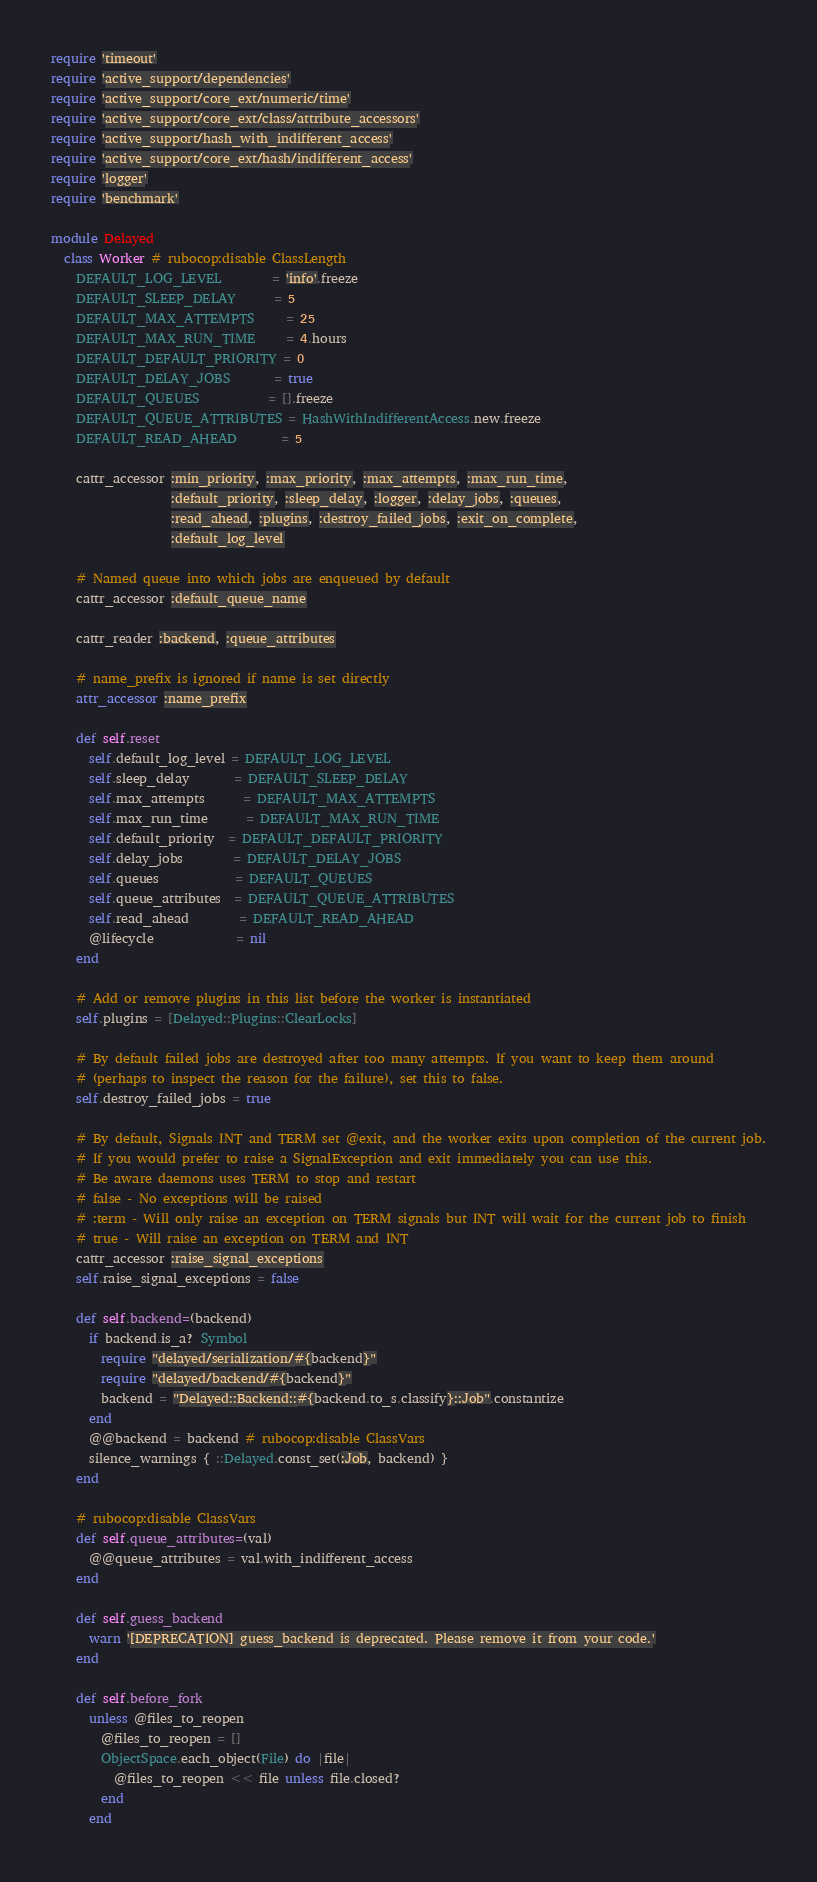<code> <loc_0><loc_0><loc_500><loc_500><_Ruby_>require 'timeout'
require 'active_support/dependencies'
require 'active_support/core_ext/numeric/time'
require 'active_support/core_ext/class/attribute_accessors'
require 'active_support/hash_with_indifferent_access'
require 'active_support/core_ext/hash/indifferent_access'
require 'logger'
require 'benchmark'

module Delayed
  class Worker # rubocop:disable ClassLength
    DEFAULT_LOG_LEVEL        = 'info'.freeze
    DEFAULT_SLEEP_DELAY      = 5
    DEFAULT_MAX_ATTEMPTS     = 25
    DEFAULT_MAX_RUN_TIME     = 4.hours
    DEFAULT_DEFAULT_PRIORITY = 0
    DEFAULT_DELAY_JOBS       = true
    DEFAULT_QUEUES           = [].freeze
    DEFAULT_QUEUE_ATTRIBUTES = HashWithIndifferentAccess.new.freeze
    DEFAULT_READ_AHEAD       = 5

    cattr_accessor :min_priority, :max_priority, :max_attempts, :max_run_time,
                   :default_priority, :sleep_delay, :logger, :delay_jobs, :queues,
                   :read_ahead, :plugins, :destroy_failed_jobs, :exit_on_complete,
                   :default_log_level

    # Named queue into which jobs are enqueued by default
    cattr_accessor :default_queue_name

    cattr_reader :backend, :queue_attributes

    # name_prefix is ignored if name is set directly
    attr_accessor :name_prefix

    def self.reset
      self.default_log_level = DEFAULT_LOG_LEVEL
      self.sleep_delay       = DEFAULT_SLEEP_DELAY
      self.max_attempts      = DEFAULT_MAX_ATTEMPTS
      self.max_run_time      = DEFAULT_MAX_RUN_TIME
      self.default_priority  = DEFAULT_DEFAULT_PRIORITY
      self.delay_jobs        = DEFAULT_DELAY_JOBS
      self.queues            = DEFAULT_QUEUES
      self.queue_attributes  = DEFAULT_QUEUE_ATTRIBUTES
      self.read_ahead        = DEFAULT_READ_AHEAD
      @lifecycle             = nil
    end

    # Add or remove plugins in this list before the worker is instantiated
    self.plugins = [Delayed::Plugins::ClearLocks]

    # By default failed jobs are destroyed after too many attempts. If you want to keep them around
    # (perhaps to inspect the reason for the failure), set this to false.
    self.destroy_failed_jobs = true

    # By default, Signals INT and TERM set @exit, and the worker exits upon completion of the current job.
    # If you would prefer to raise a SignalException and exit immediately you can use this.
    # Be aware daemons uses TERM to stop and restart
    # false - No exceptions will be raised
    # :term - Will only raise an exception on TERM signals but INT will wait for the current job to finish
    # true - Will raise an exception on TERM and INT
    cattr_accessor :raise_signal_exceptions
    self.raise_signal_exceptions = false

    def self.backend=(backend)
      if backend.is_a? Symbol
        require "delayed/serialization/#{backend}"
        require "delayed/backend/#{backend}"
        backend = "Delayed::Backend::#{backend.to_s.classify}::Job".constantize
      end
      @@backend = backend # rubocop:disable ClassVars
      silence_warnings { ::Delayed.const_set(:Job, backend) }
    end

    # rubocop:disable ClassVars
    def self.queue_attributes=(val)
      @@queue_attributes = val.with_indifferent_access
    end

    def self.guess_backend
      warn '[DEPRECATION] guess_backend is deprecated. Please remove it from your code.'
    end

    def self.before_fork
      unless @files_to_reopen
        @files_to_reopen = []
        ObjectSpace.each_object(File) do |file|
          @files_to_reopen << file unless file.closed?
        end
      end
</code> 